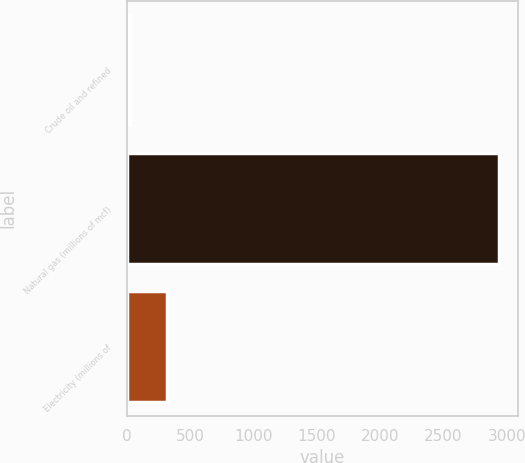<chart> <loc_0><loc_0><loc_500><loc_500><bar_chart><fcel>Crude oil and refined<fcel>Natural gas (millions of mcf)<fcel>Electricity (millions of<nl><fcel>26<fcel>2938<fcel>317.2<nl></chart> 